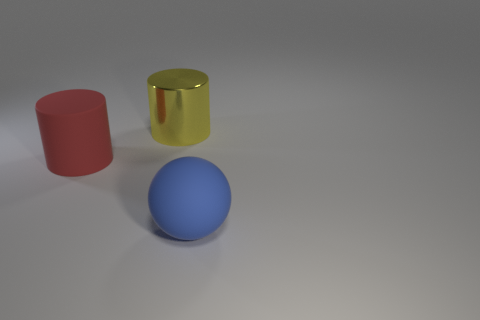There is a rubber object behind the sphere; is its size the same as the object that is on the right side of the yellow cylinder?
Provide a short and direct response. Yes. There is a big object that is left of the big blue matte sphere and in front of the yellow metal object; what is its material?
Offer a terse response. Rubber. Is the number of large matte cylinders less than the number of green blocks?
Give a very brief answer. No. How big is the matte object that is left of the rubber thing that is to the right of the red cylinder?
Ensure brevity in your answer.  Large. What shape is the large rubber thing left of the large object that is behind the big rubber thing on the left side of the blue thing?
Ensure brevity in your answer.  Cylinder. There is a big cylinder that is made of the same material as the blue object; what is its color?
Provide a succinct answer. Red. There is a big rubber object behind the large matte object in front of the large rubber thing that is behind the blue sphere; what color is it?
Your response must be concise. Red. What number of spheres are blue objects or small cyan matte things?
Keep it short and to the point. 1. Is the color of the large rubber ball the same as the cylinder that is right of the red object?
Provide a short and direct response. No. What is the color of the metallic thing?
Provide a short and direct response. Yellow. 